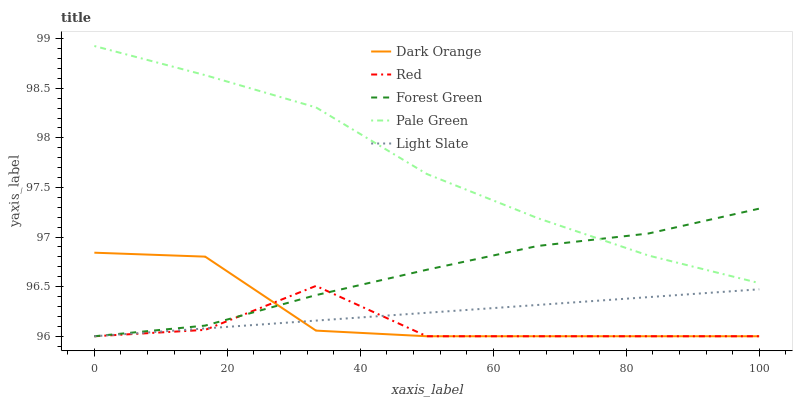Does Red have the minimum area under the curve?
Answer yes or no. Yes. Does Pale Green have the maximum area under the curve?
Answer yes or no. Yes. Does Dark Orange have the minimum area under the curve?
Answer yes or no. No. Does Dark Orange have the maximum area under the curve?
Answer yes or no. No. Is Light Slate the smoothest?
Answer yes or no. Yes. Is Red the roughest?
Answer yes or no. Yes. Is Dark Orange the smoothest?
Answer yes or no. No. Is Dark Orange the roughest?
Answer yes or no. No. Does Light Slate have the lowest value?
Answer yes or no. Yes. Does Pale Green have the lowest value?
Answer yes or no. No. Does Pale Green have the highest value?
Answer yes or no. Yes. Does Dark Orange have the highest value?
Answer yes or no. No. Is Dark Orange less than Pale Green?
Answer yes or no. Yes. Is Pale Green greater than Light Slate?
Answer yes or no. Yes. Does Pale Green intersect Forest Green?
Answer yes or no. Yes. Is Pale Green less than Forest Green?
Answer yes or no. No. Is Pale Green greater than Forest Green?
Answer yes or no. No. Does Dark Orange intersect Pale Green?
Answer yes or no. No. 